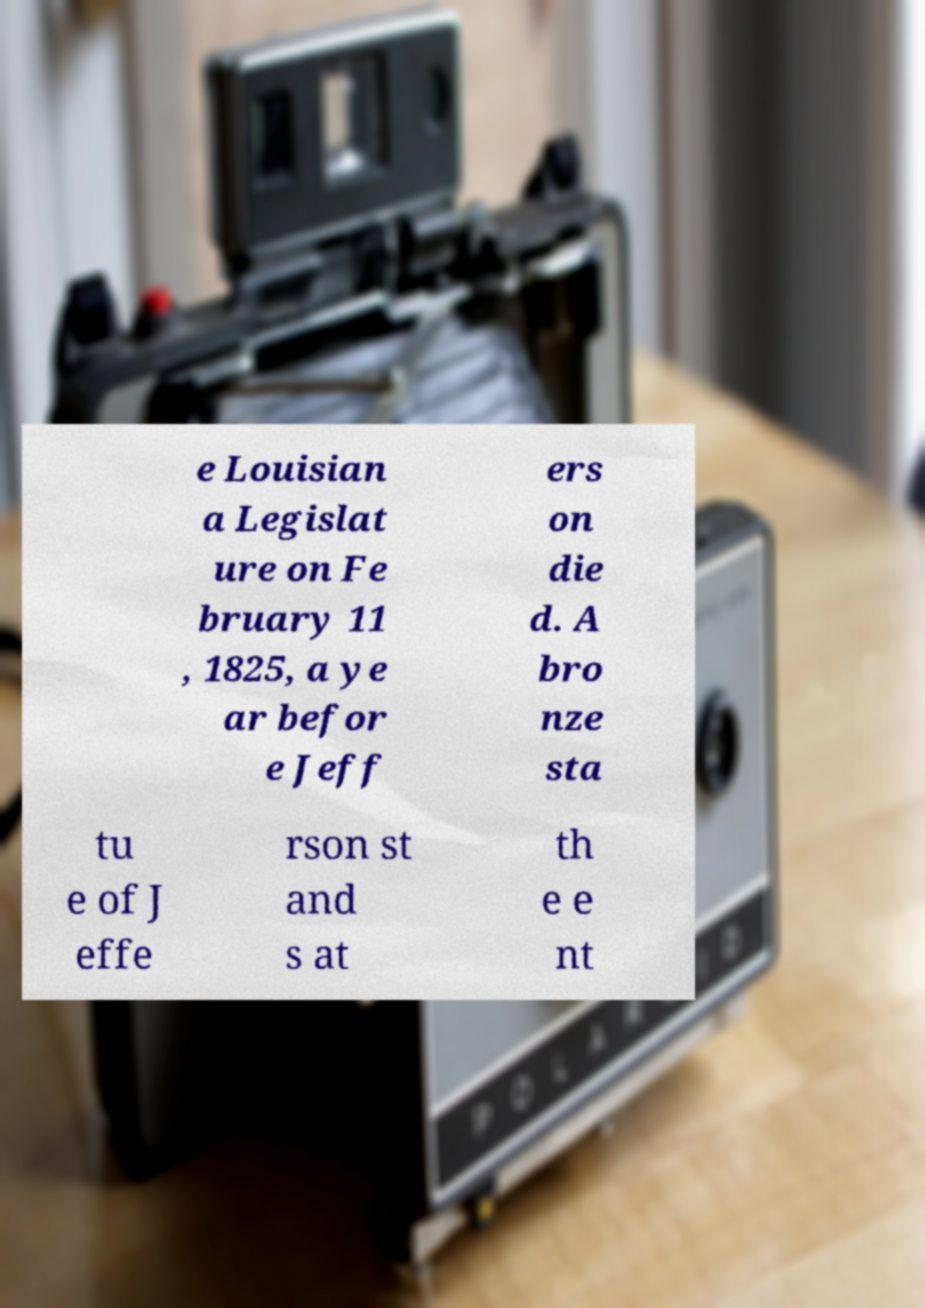For documentation purposes, I need the text within this image transcribed. Could you provide that? e Louisian a Legislat ure on Fe bruary 11 , 1825, a ye ar befor e Jeff ers on die d. A bro nze sta tu e of J effe rson st and s at th e e nt 